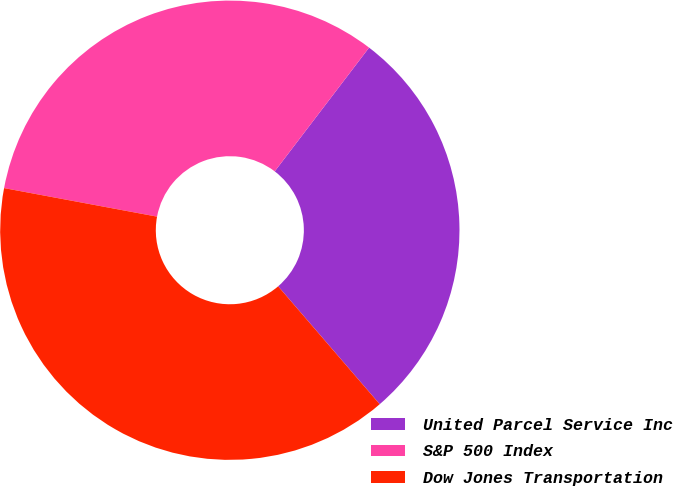<chart> <loc_0><loc_0><loc_500><loc_500><pie_chart><fcel>United Parcel Service Inc<fcel>S&P 500 Index<fcel>Dow Jones Transportation<nl><fcel>28.31%<fcel>32.43%<fcel>39.25%<nl></chart> 